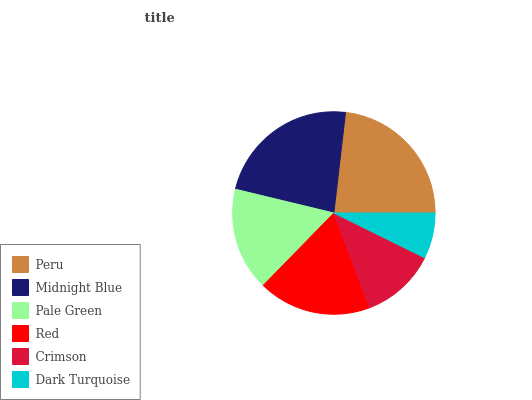Is Dark Turquoise the minimum?
Answer yes or no. Yes. Is Peru the maximum?
Answer yes or no. Yes. Is Midnight Blue the minimum?
Answer yes or no. No. Is Midnight Blue the maximum?
Answer yes or no. No. Is Peru greater than Midnight Blue?
Answer yes or no. Yes. Is Midnight Blue less than Peru?
Answer yes or no. Yes. Is Midnight Blue greater than Peru?
Answer yes or no. No. Is Peru less than Midnight Blue?
Answer yes or no. No. Is Red the high median?
Answer yes or no. Yes. Is Pale Green the low median?
Answer yes or no. Yes. Is Midnight Blue the high median?
Answer yes or no. No. Is Dark Turquoise the low median?
Answer yes or no. No. 